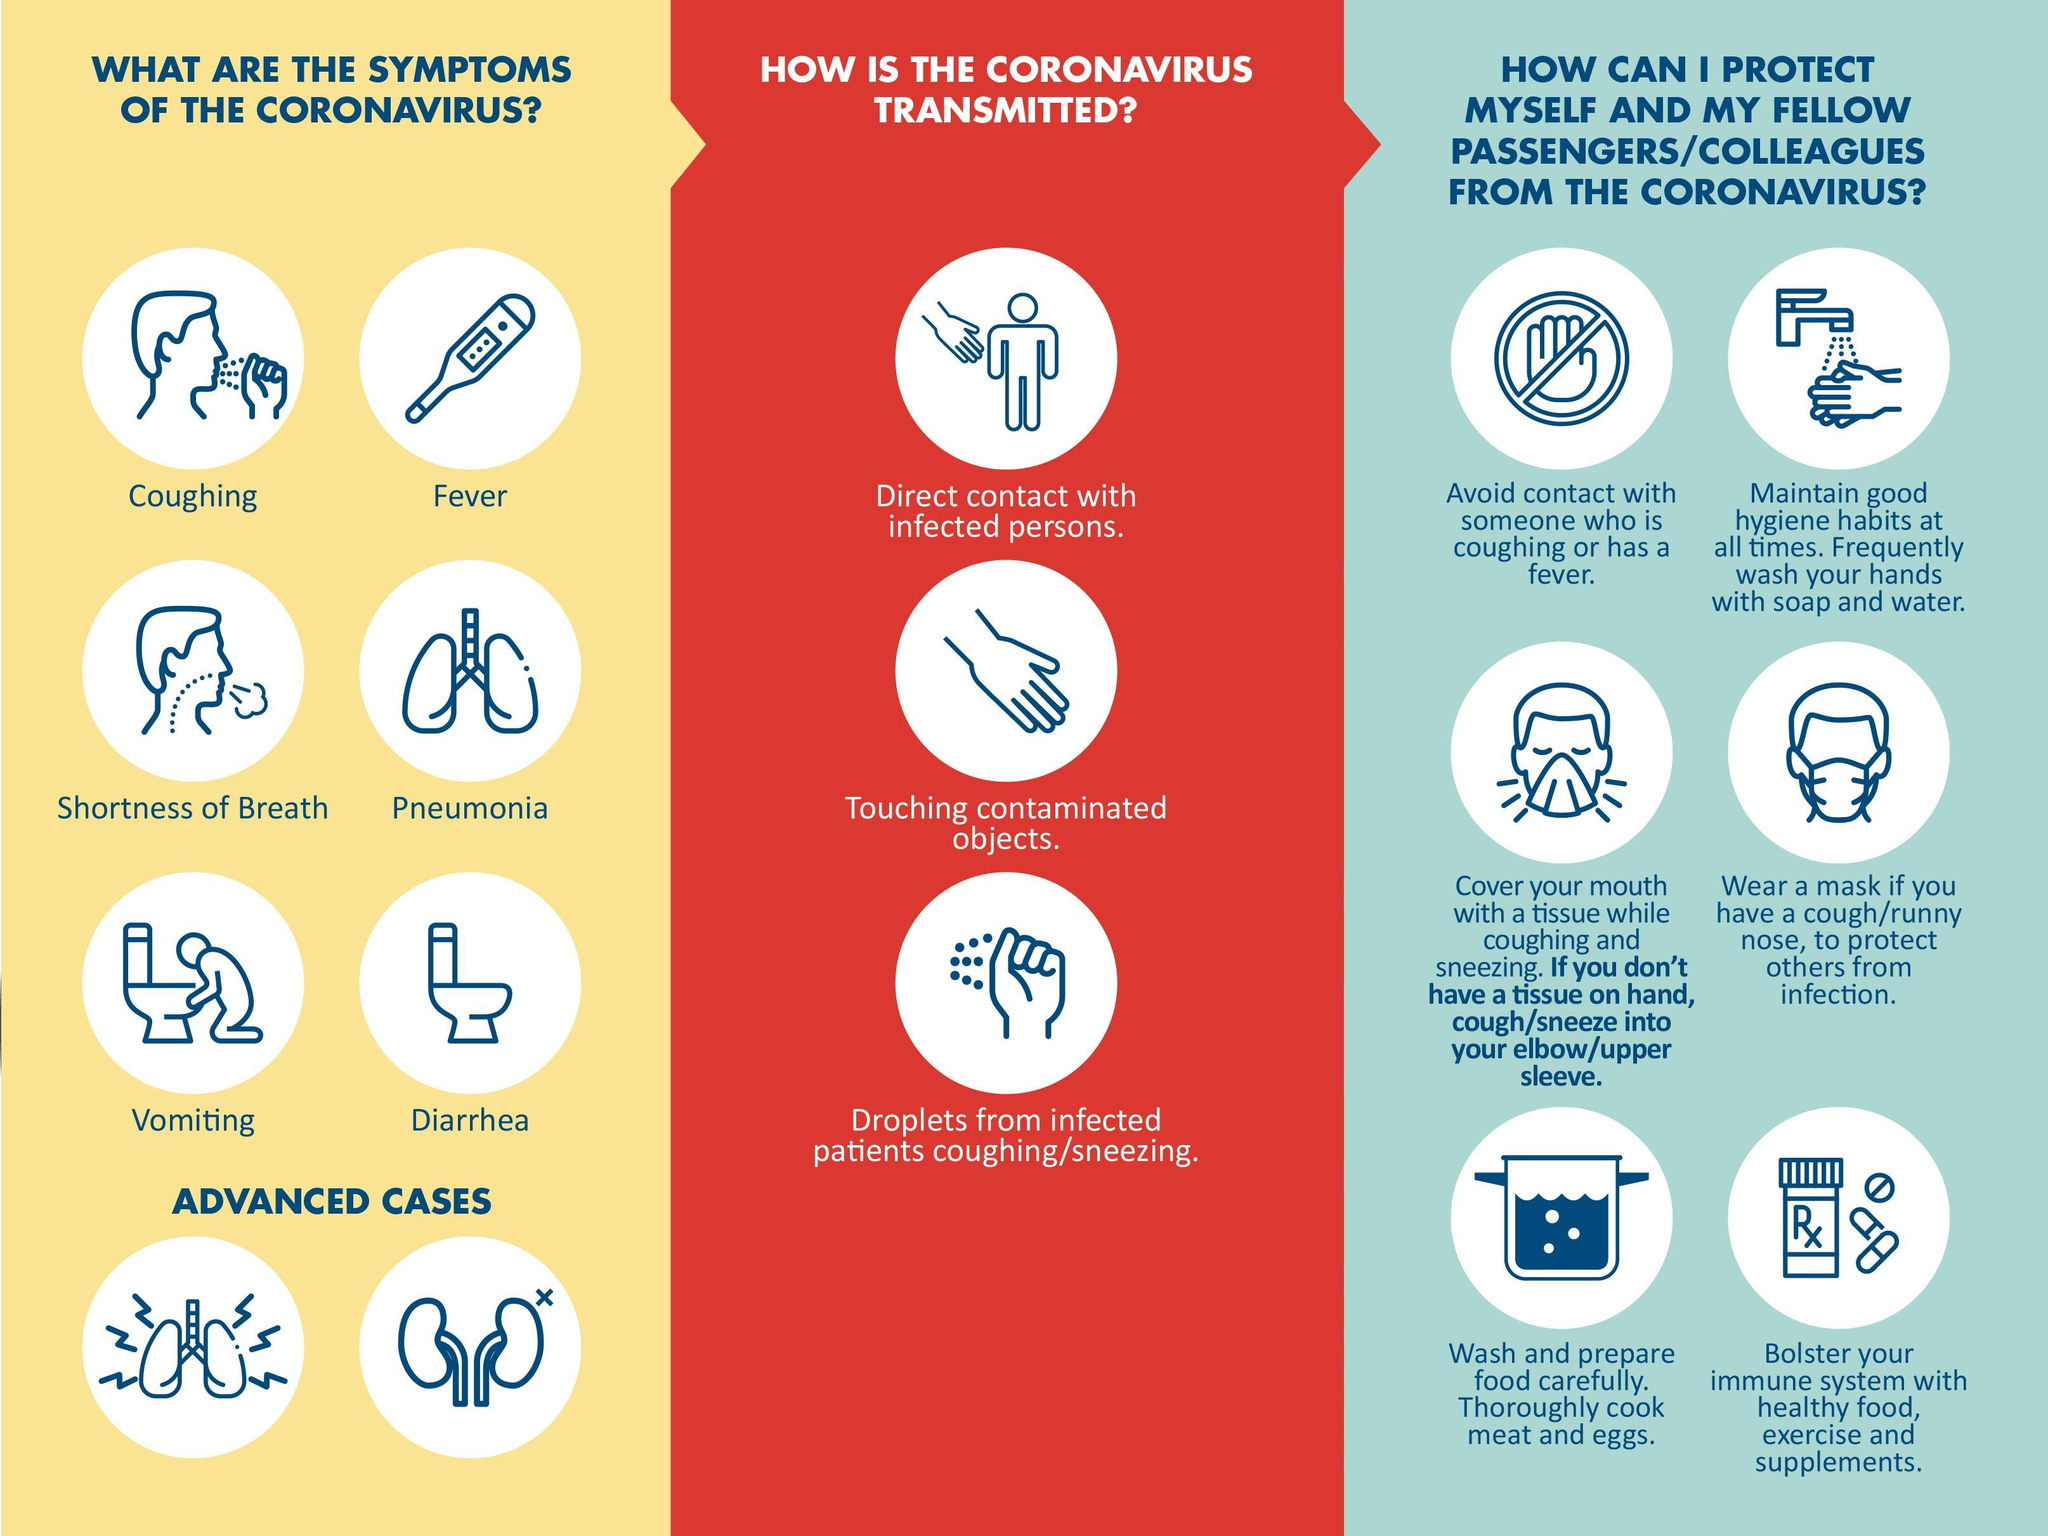what does the thermometer indicate
Answer the question with a short phrase. fever How many ways can the coronavirus get transmitted 3 What symptoms do the toilet bowls indicate diarrhea, vomiting How many symptoms of coronovirus is shown 6 What can bolster our immune system healthy food, exercise and supplements What symptom does the picture of the lung indicate Pneumonia In advanced cases, what is affected, lungs and stomach or lungs and kidney lungs and kidney 